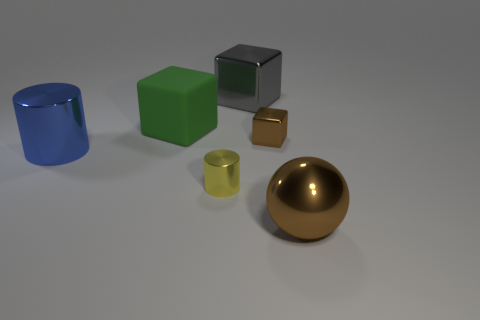What is the size of the cylinder on the left side of the green block?
Make the answer very short. Large. Are there any purple rubber cylinders of the same size as the gray block?
Provide a succinct answer. No. There is a cylinder that is in front of the blue cylinder; is its size the same as the big green rubber thing?
Offer a very short reply. No. How big is the shiny sphere?
Give a very brief answer. Large. There is a metallic cylinder behind the shiny cylinder that is in front of the big blue metallic object in front of the brown metallic block; what color is it?
Your answer should be compact. Blue. There is a tiny block that is in front of the big rubber cube; is its color the same as the large metal ball?
Your answer should be very brief. Yes. What number of brown objects are in front of the tiny yellow cylinder and behind the brown sphere?
Offer a terse response. 0. There is a gray object that is the same shape as the small brown metallic object; what is its size?
Provide a succinct answer. Large. What number of metallic blocks are on the left side of the shiny cube to the right of the big metal block that is right of the rubber cube?
Provide a short and direct response. 1. The small object in front of the brown thing that is to the left of the ball is what color?
Make the answer very short. Yellow. 